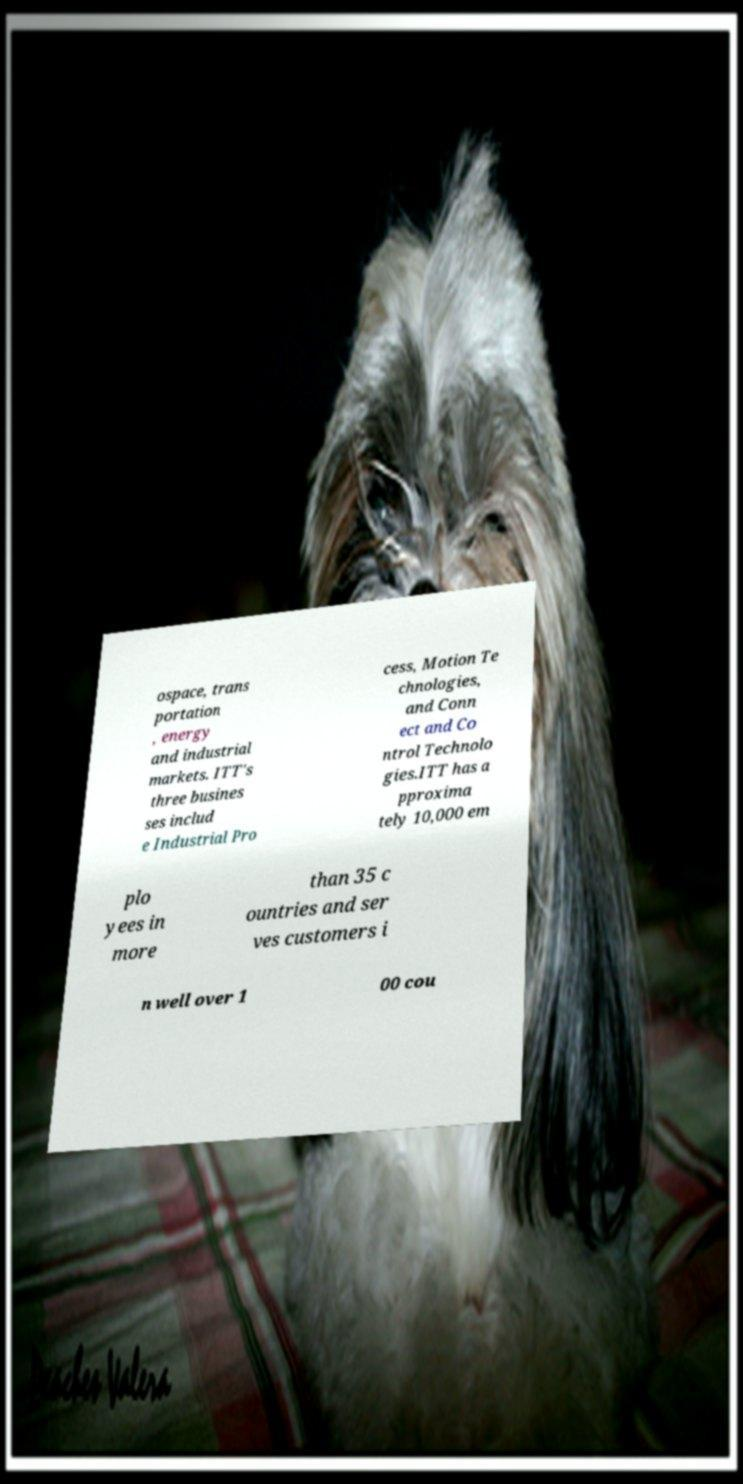For documentation purposes, I need the text within this image transcribed. Could you provide that? ospace, trans portation , energy and industrial markets. ITT's three busines ses includ e Industrial Pro cess, Motion Te chnologies, and Conn ect and Co ntrol Technolo gies.ITT has a pproxima tely 10,000 em plo yees in more than 35 c ountries and ser ves customers i n well over 1 00 cou 